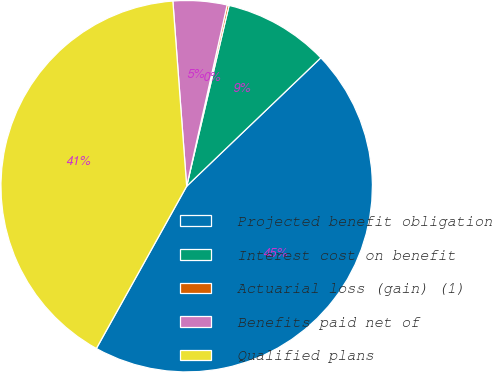Convert chart. <chart><loc_0><loc_0><loc_500><loc_500><pie_chart><fcel>Projected benefit obligation<fcel>Interest cost on benefit<fcel>Actuarial loss (gain) (1)<fcel>Benefits paid net of<fcel>Qualified plans<nl><fcel>45.23%<fcel>9.18%<fcel>0.17%<fcel>4.68%<fcel>40.73%<nl></chart> 